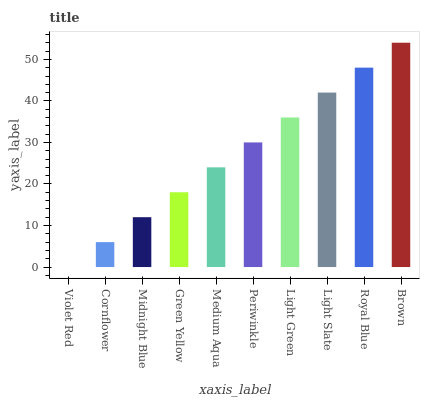Is Violet Red the minimum?
Answer yes or no. Yes. Is Brown the maximum?
Answer yes or no. Yes. Is Cornflower the minimum?
Answer yes or no. No. Is Cornflower the maximum?
Answer yes or no. No. Is Cornflower greater than Violet Red?
Answer yes or no. Yes. Is Violet Red less than Cornflower?
Answer yes or no. Yes. Is Violet Red greater than Cornflower?
Answer yes or no. No. Is Cornflower less than Violet Red?
Answer yes or no. No. Is Periwinkle the high median?
Answer yes or no. Yes. Is Medium Aqua the low median?
Answer yes or no. Yes. Is Midnight Blue the high median?
Answer yes or no. No. Is Periwinkle the low median?
Answer yes or no. No. 